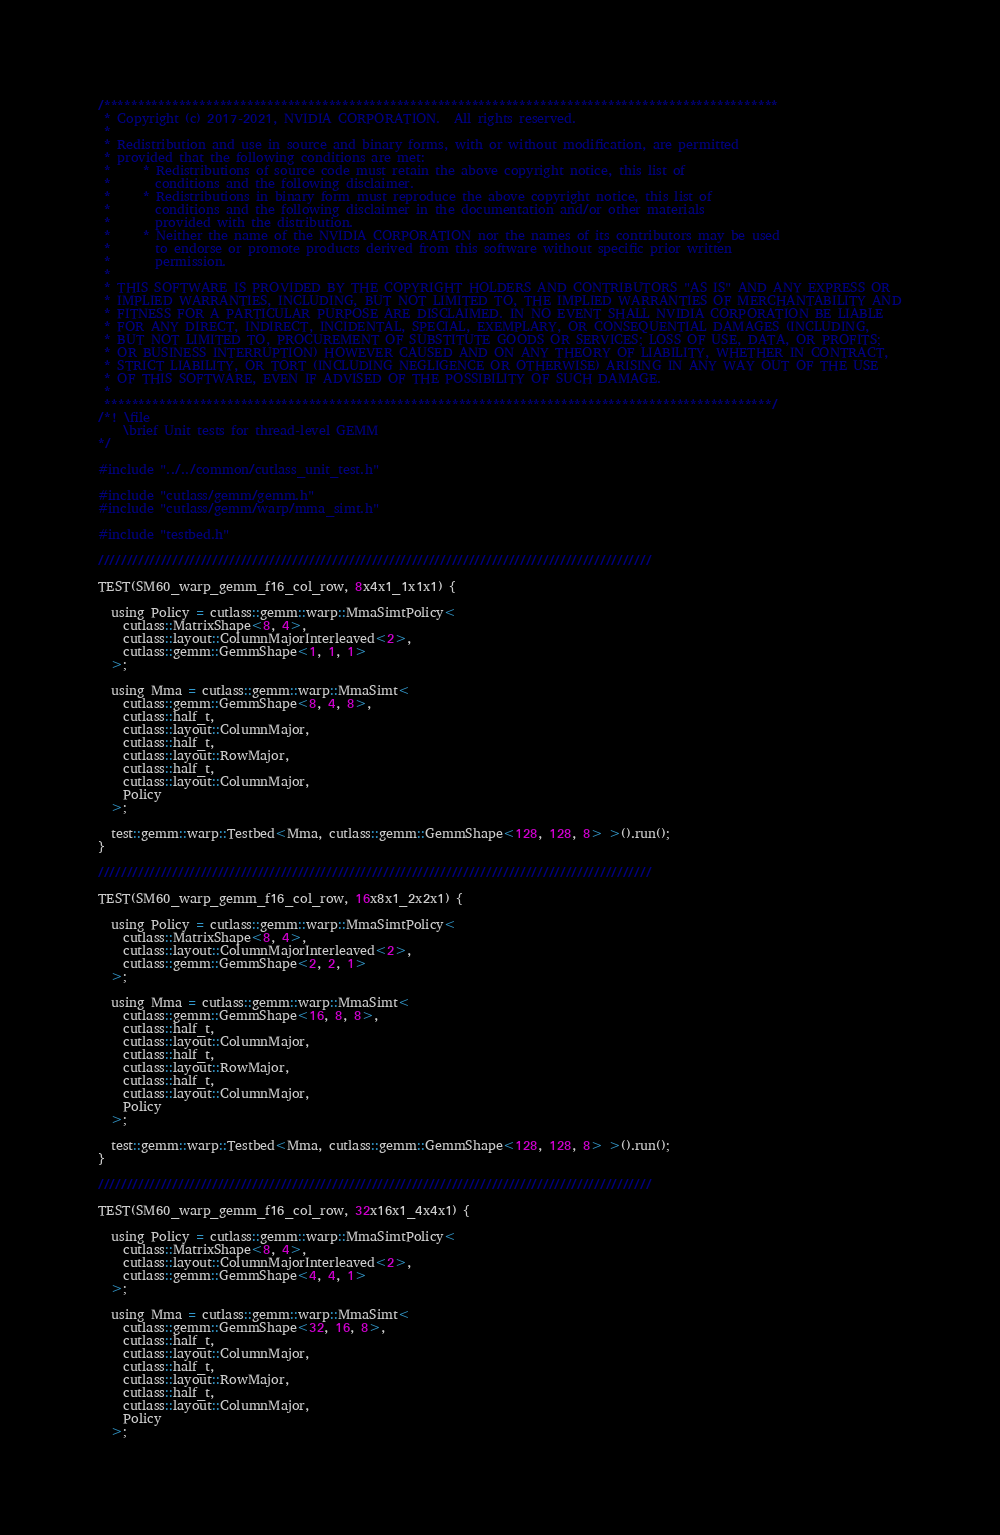<code> <loc_0><loc_0><loc_500><loc_500><_Cuda_>/***************************************************************************************************
 * Copyright (c) 2017-2021, NVIDIA CORPORATION.  All rights reserved.
 *
 * Redistribution and use in source and binary forms, with or without modification, are permitted
 * provided that the following conditions are met:
 *     * Redistributions of source code must retain the above copyright notice, this list of
 *       conditions and the following disclaimer.
 *     * Redistributions in binary form must reproduce the above copyright notice, this list of
 *       conditions and the following disclaimer in the documentation and/or other materials
 *       provided with the distribution.
 *     * Neither the name of the NVIDIA CORPORATION nor the names of its contributors may be used
 *       to endorse or promote products derived from this software without specific prior written
 *       permission.
 *
 * THIS SOFTWARE IS PROVIDED BY THE COPYRIGHT HOLDERS AND CONTRIBUTORS "AS IS" AND ANY EXPRESS OR
 * IMPLIED WARRANTIES, INCLUDING, BUT NOT LIMITED TO, THE IMPLIED WARRANTIES OF MERCHANTABILITY AND
 * FITNESS FOR A PARTICULAR PURPOSE ARE DISCLAIMED. IN NO EVENT SHALL NVIDIA CORPORATION BE LIABLE
 * FOR ANY DIRECT, INDIRECT, INCIDENTAL, SPECIAL, EXEMPLARY, OR CONSEQUENTIAL DAMAGES (INCLUDING,
 * BUT NOT LIMITED TO, PROCUREMENT OF SUBSTITUTE GOODS OR SERVICES; LOSS OF USE, DATA, OR PROFITS;
 * OR BUSINESS INTERRUPTION) HOWEVER CAUSED AND ON ANY THEORY OF LIABILITY, WHETHER IN CONTRACT,
 * STRICT LIABILITY, OR TORT (INCLUDING NEGLIGENCE OR OTHERWISE) ARISING IN ANY WAY OUT OF THE USE
 * OF THIS SOFTWARE, EVEN IF ADVISED OF THE POSSIBILITY OF SUCH DAMAGE.
 *
 **************************************************************************************************/
/*! \file
    \brief Unit tests for thread-level GEMM
*/

#include "../../common/cutlass_unit_test.h"

#include "cutlass/gemm/gemm.h"
#include "cutlass/gemm/warp/mma_simt.h"

#include "testbed.h"

/////////////////////////////////////////////////////////////////////////////////////////////////

TEST(SM60_warp_gemm_f16_col_row, 8x4x1_1x1x1) {

  using Policy = cutlass::gemm::warp::MmaSimtPolicy<
    cutlass::MatrixShape<8, 4>,
    cutlass::layout::ColumnMajorInterleaved<2>,
    cutlass::gemm::GemmShape<1, 1, 1>
  >;

  using Mma = cutlass::gemm::warp::MmaSimt<
    cutlass::gemm::GemmShape<8, 4, 8>,
    cutlass::half_t,
    cutlass::layout::ColumnMajor,
    cutlass::half_t,
    cutlass::layout::RowMajor,
    cutlass::half_t,
    cutlass::layout::ColumnMajor,
    Policy
  >;

  test::gemm::warp::Testbed<Mma, cutlass::gemm::GemmShape<128, 128, 8> >().run();
}

/////////////////////////////////////////////////////////////////////////////////////////////////

TEST(SM60_warp_gemm_f16_col_row, 16x8x1_2x2x1) {

  using Policy = cutlass::gemm::warp::MmaSimtPolicy<
    cutlass::MatrixShape<8, 4>,
    cutlass::layout::ColumnMajorInterleaved<2>,
    cutlass::gemm::GemmShape<2, 2, 1>
  >;

  using Mma = cutlass::gemm::warp::MmaSimt<
    cutlass::gemm::GemmShape<16, 8, 8>,
    cutlass::half_t,
    cutlass::layout::ColumnMajor,
    cutlass::half_t,
    cutlass::layout::RowMajor,
    cutlass::half_t,
    cutlass::layout::ColumnMajor,
    Policy
  >;

  test::gemm::warp::Testbed<Mma, cutlass::gemm::GemmShape<128, 128, 8> >().run();
}

/////////////////////////////////////////////////////////////////////////////////////////////////

TEST(SM60_warp_gemm_f16_col_row, 32x16x1_4x4x1) {

  using Policy = cutlass::gemm::warp::MmaSimtPolicy<
    cutlass::MatrixShape<8, 4>,
    cutlass::layout::ColumnMajorInterleaved<2>,
    cutlass::gemm::GemmShape<4, 4, 1>
  >;

  using Mma = cutlass::gemm::warp::MmaSimt<
    cutlass::gemm::GemmShape<32, 16, 8>,
    cutlass::half_t,
    cutlass::layout::ColumnMajor,
    cutlass::half_t,
    cutlass::layout::RowMajor,
    cutlass::half_t,
    cutlass::layout::ColumnMajor,
    Policy
  >;
</code> 